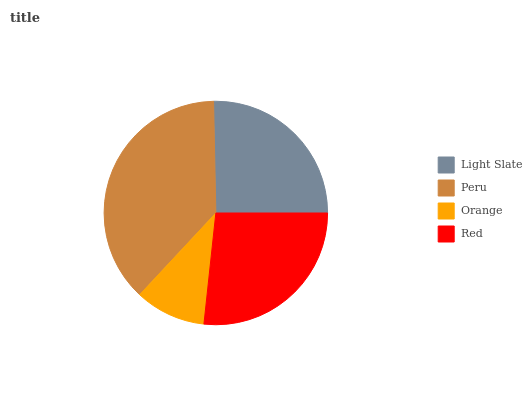Is Orange the minimum?
Answer yes or no. Yes. Is Peru the maximum?
Answer yes or no. Yes. Is Peru the minimum?
Answer yes or no. No. Is Orange the maximum?
Answer yes or no. No. Is Peru greater than Orange?
Answer yes or no. Yes. Is Orange less than Peru?
Answer yes or no. Yes. Is Orange greater than Peru?
Answer yes or no. No. Is Peru less than Orange?
Answer yes or no. No. Is Red the high median?
Answer yes or no. Yes. Is Light Slate the low median?
Answer yes or no. Yes. Is Peru the high median?
Answer yes or no. No. Is Orange the low median?
Answer yes or no. No. 